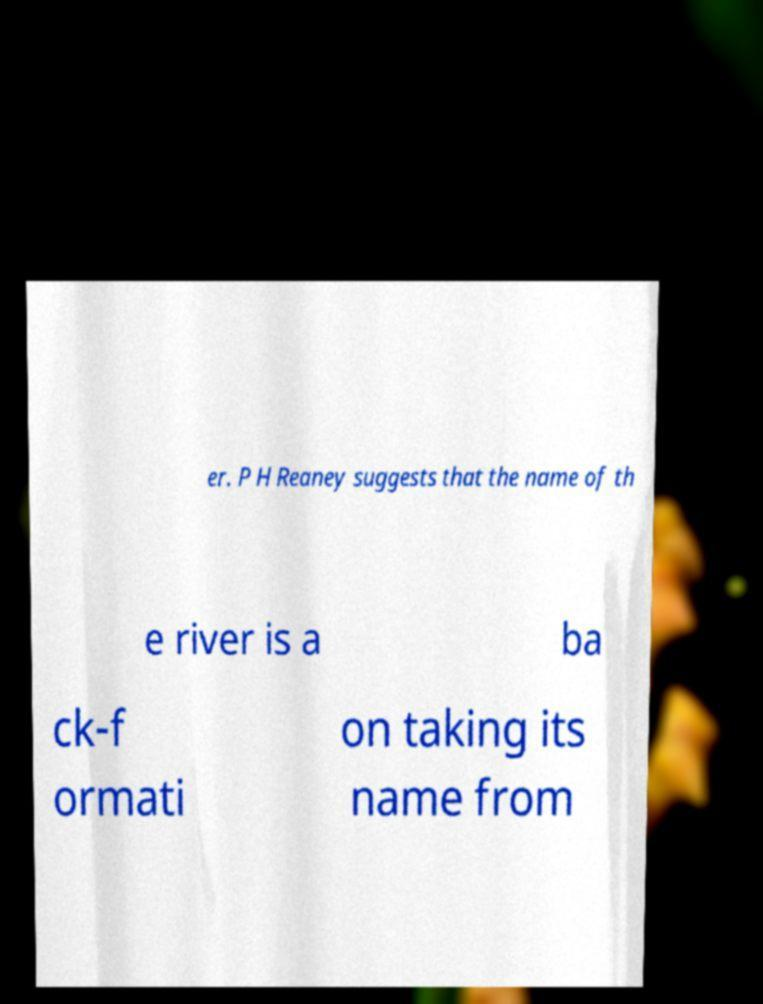There's text embedded in this image that I need extracted. Can you transcribe it verbatim? er. P H Reaney suggests that the name of th e river is a ba ck-f ormati on taking its name from 